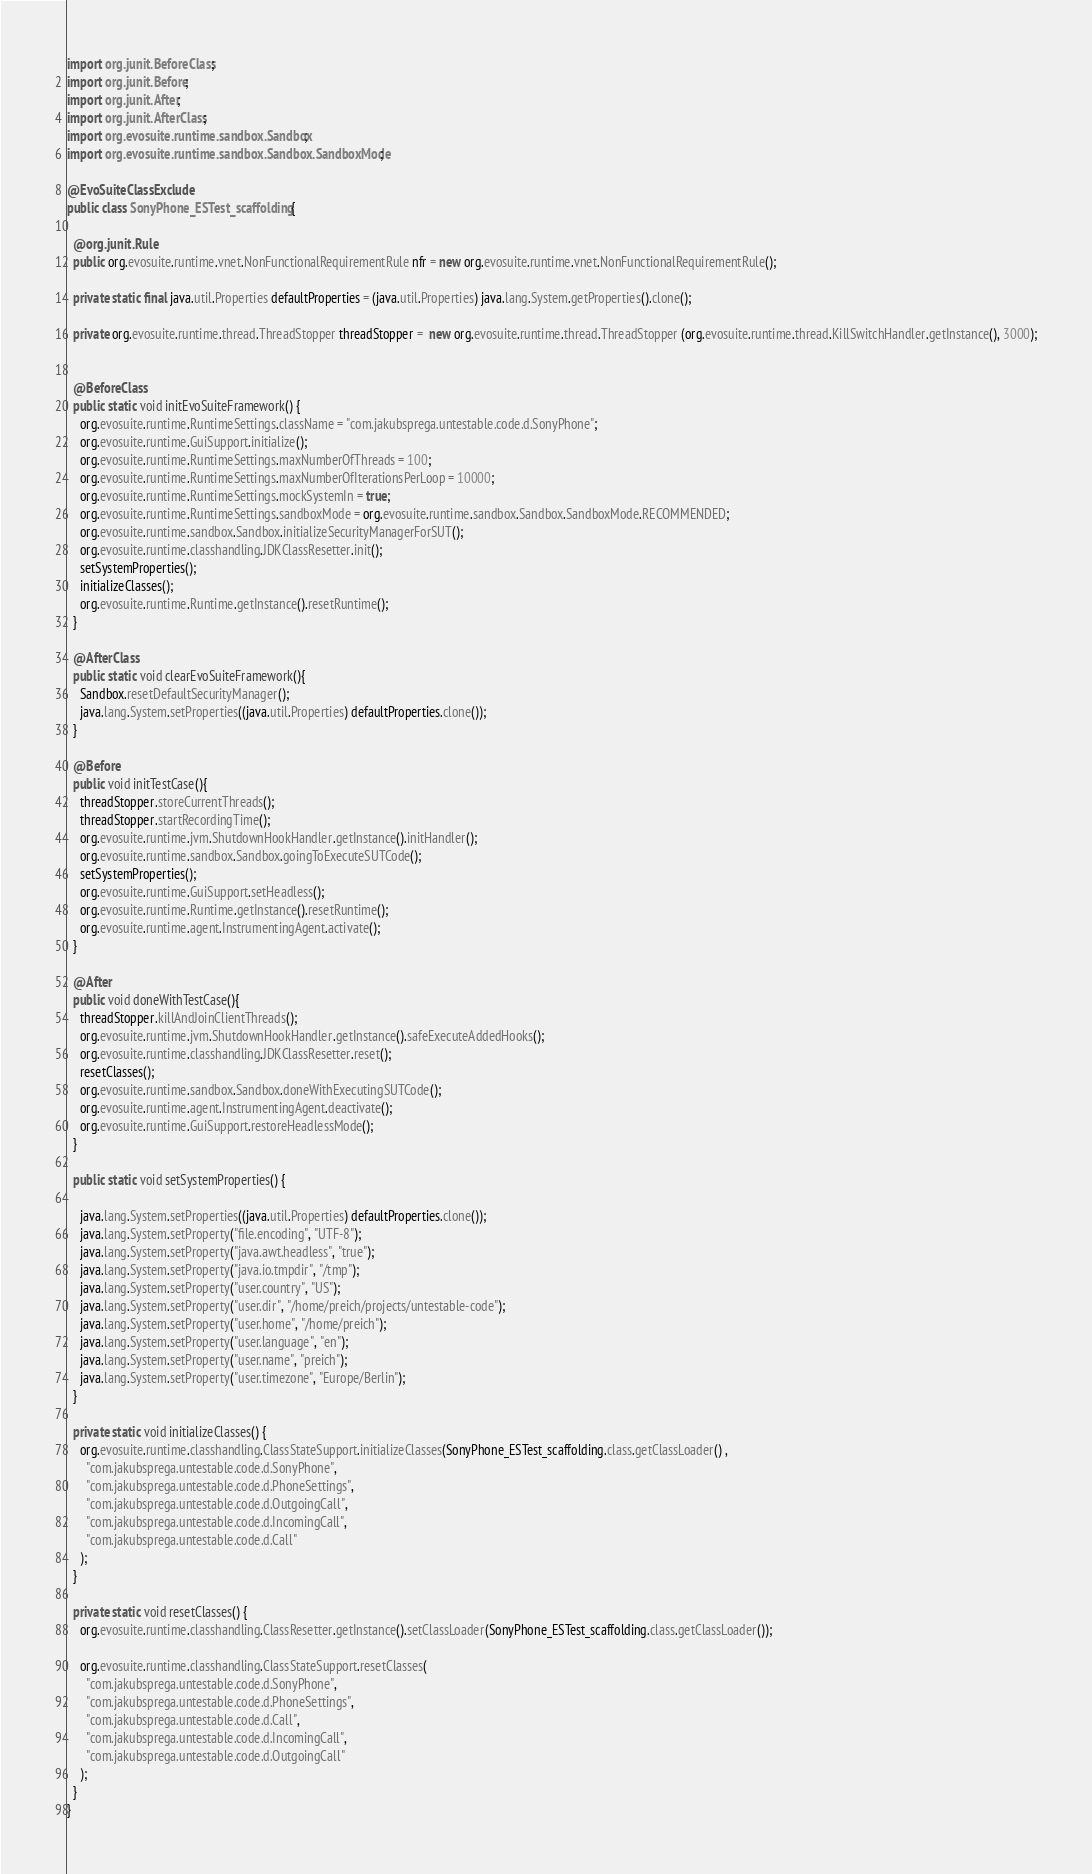Convert code to text. <code><loc_0><loc_0><loc_500><loc_500><_Java_>import org.junit.BeforeClass;
import org.junit.Before;
import org.junit.After;
import org.junit.AfterClass;
import org.evosuite.runtime.sandbox.Sandbox;
import org.evosuite.runtime.sandbox.Sandbox.SandboxMode;

@EvoSuiteClassExclude
public class SonyPhone_ESTest_scaffolding {

  @org.junit.Rule 
  public org.evosuite.runtime.vnet.NonFunctionalRequirementRule nfr = new org.evosuite.runtime.vnet.NonFunctionalRequirementRule();

  private static final java.util.Properties defaultProperties = (java.util.Properties) java.lang.System.getProperties().clone(); 

  private org.evosuite.runtime.thread.ThreadStopper threadStopper =  new org.evosuite.runtime.thread.ThreadStopper (org.evosuite.runtime.thread.KillSwitchHandler.getInstance(), 3000);


  @BeforeClass 
  public static void initEvoSuiteFramework() { 
    org.evosuite.runtime.RuntimeSettings.className = "com.jakubsprega.untestable.code.d.SonyPhone"; 
    org.evosuite.runtime.GuiSupport.initialize(); 
    org.evosuite.runtime.RuntimeSettings.maxNumberOfThreads = 100; 
    org.evosuite.runtime.RuntimeSettings.maxNumberOfIterationsPerLoop = 10000; 
    org.evosuite.runtime.RuntimeSettings.mockSystemIn = true; 
    org.evosuite.runtime.RuntimeSettings.sandboxMode = org.evosuite.runtime.sandbox.Sandbox.SandboxMode.RECOMMENDED; 
    org.evosuite.runtime.sandbox.Sandbox.initializeSecurityManagerForSUT(); 
    org.evosuite.runtime.classhandling.JDKClassResetter.init();
    setSystemProperties();
    initializeClasses();
    org.evosuite.runtime.Runtime.getInstance().resetRuntime(); 
  } 

  @AfterClass 
  public static void clearEvoSuiteFramework(){ 
    Sandbox.resetDefaultSecurityManager(); 
    java.lang.System.setProperties((java.util.Properties) defaultProperties.clone()); 
  } 

  @Before 
  public void initTestCase(){ 
    threadStopper.storeCurrentThreads();
    threadStopper.startRecordingTime();
    org.evosuite.runtime.jvm.ShutdownHookHandler.getInstance().initHandler(); 
    org.evosuite.runtime.sandbox.Sandbox.goingToExecuteSUTCode(); 
    setSystemProperties(); 
    org.evosuite.runtime.GuiSupport.setHeadless(); 
    org.evosuite.runtime.Runtime.getInstance().resetRuntime(); 
    org.evosuite.runtime.agent.InstrumentingAgent.activate(); 
  } 

  @After 
  public void doneWithTestCase(){ 
    threadStopper.killAndJoinClientThreads();
    org.evosuite.runtime.jvm.ShutdownHookHandler.getInstance().safeExecuteAddedHooks(); 
    org.evosuite.runtime.classhandling.JDKClassResetter.reset(); 
    resetClasses(); 
    org.evosuite.runtime.sandbox.Sandbox.doneWithExecutingSUTCode(); 
    org.evosuite.runtime.agent.InstrumentingAgent.deactivate(); 
    org.evosuite.runtime.GuiSupport.restoreHeadlessMode(); 
  } 

  public static void setSystemProperties() {
 
    java.lang.System.setProperties((java.util.Properties) defaultProperties.clone()); 
    java.lang.System.setProperty("file.encoding", "UTF-8"); 
    java.lang.System.setProperty("java.awt.headless", "true"); 
    java.lang.System.setProperty("java.io.tmpdir", "/tmp"); 
    java.lang.System.setProperty("user.country", "US"); 
    java.lang.System.setProperty("user.dir", "/home/preich/projects/untestable-code"); 
    java.lang.System.setProperty("user.home", "/home/preich"); 
    java.lang.System.setProperty("user.language", "en"); 
    java.lang.System.setProperty("user.name", "preich"); 
    java.lang.System.setProperty("user.timezone", "Europe/Berlin"); 
  }

  private static void initializeClasses() {
    org.evosuite.runtime.classhandling.ClassStateSupport.initializeClasses(SonyPhone_ESTest_scaffolding.class.getClassLoader() ,
      "com.jakubsprega.untestable.code.d.SonyPhone",
      "com.jakubsprega.untestable.code.d.PhoneSettings",
      "com.jakubsprega.untestable.code.d.OutgoingCall",
      "com.jakubsprega.untestable.code.d.IncomingCall",
      "com.jakubsprega.untestable.code.d.Call"
    );
  } 

  private static void resetClasses() {
    org.evosuite.runtime.classhandling.ClassResetter.getInstance().setClassLoader(SonyPhone_ESTest_scaffolding.class.getClassLoader()); 

    org.evosuite.runtime.classhandling.ClassStateSupport.resetClasses(
      "com.jakubsprega.untestable.code.d.SonyPhone",
      "com.jakubsprega.untestable.code.d.PhoneSettings",
      "com.jakubsprega.untestable.code.d.Call",
      "com.jakubsprega.untestable.code.d.IncomingCall",
      "com.jakubsprega.untestable.code.d.OutgoingCall"
    );
  }
}
</code> 